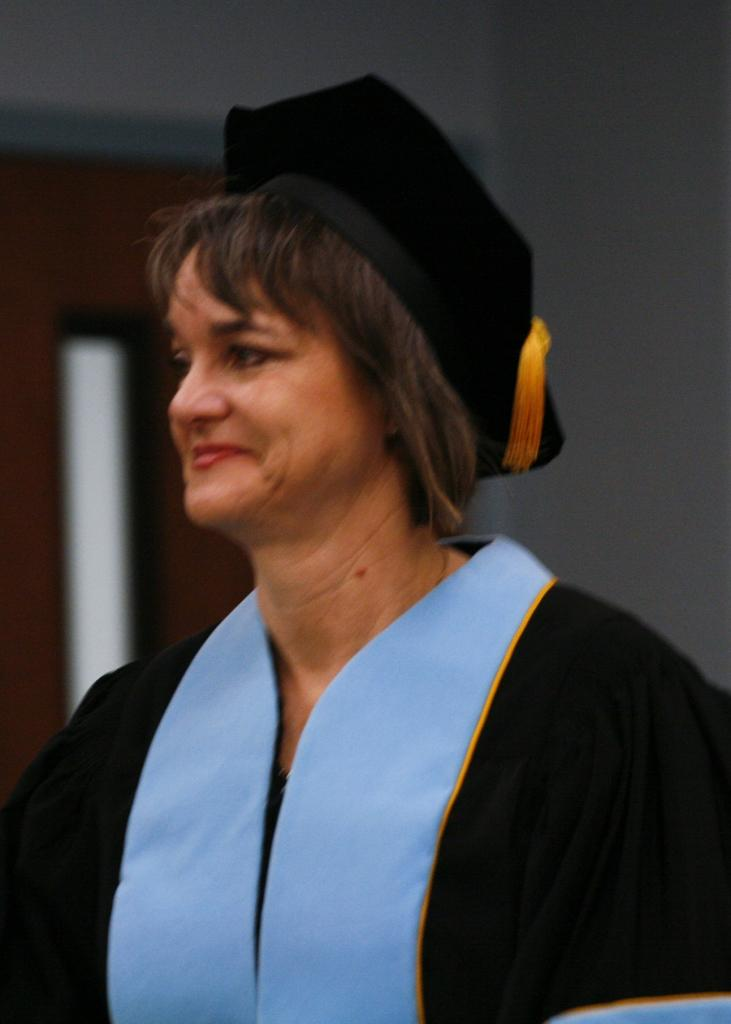Who is present in the image? There is a woman in the image. What is the woman wearing on her head? The woman is wearing a cap. What can be seen in the background of the image? There is a door and a wall in the background of the image. Is there a servant holding a chain and standing in the shade in the image? No, there is no servant, chain, or shade present in the image. 